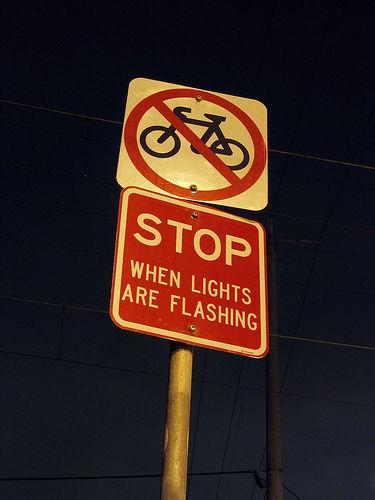Are bicycles allowed?
Answer briefly. No. What does the stop sign mean?
Answer briefly. No bikes. What does the lower sign say?
Answer briefly. Stop when lights are flashing. What color is the stop sign?
Keep it brief. Red. 